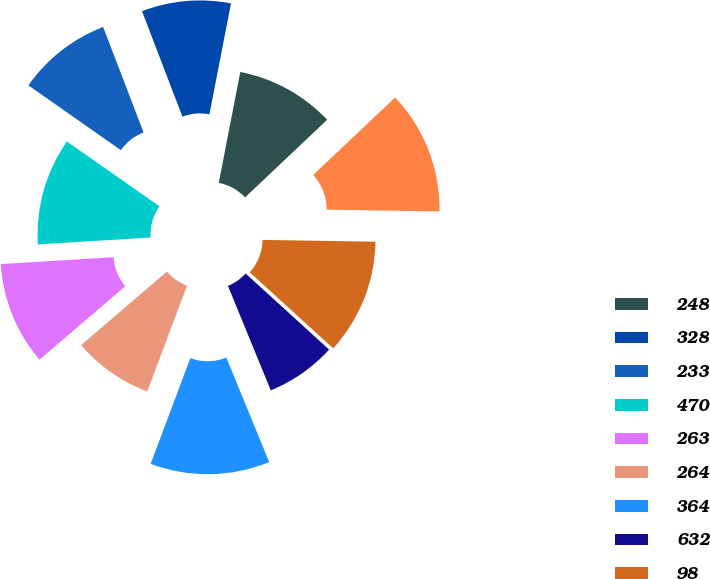Convert chart to OTSL. <chart><loc_0><loc_0><loc_500><loc_500><pie_chart><fcel>248<fcel>328<fcel>233<fcel>470<fcel>263<fcel>264<fcel>364<fcel>632<fcel>98<fcel>427<nl><fcel>9.89%<fcel>8.88%<fcel>9.45%<fcel>10.7%<fcel>10.3%<fcel>8.01%<fcel>11.91%<fcel>7.04%<fcel>11.51%<fcel>12.31%<nl></chart> 